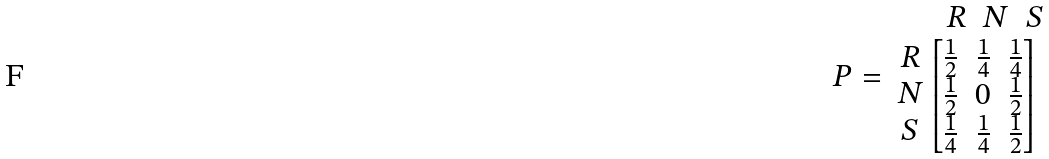<formula> <loc_0><loc_0><loc_500><loc_500>P = \begin{array} { r } \begin{matrix} R & N & S \end{matrix} \\ \begin{matrix} R \\ N \\ S \end{matrix} \begin{bmatrix} \frac { 1 } { 2 } & \frac { 1 } { 4 } & \frac { 1 } { 4 } \\ \frac { 1 } { 2 } & 0 & \frac { 1 } { 2 } \\ \frac { 1 } { 4 } & \frac { 1 } { 4 } & \frac { 1 } { 2 } \\ \end{bmatrix} \ \end{array}</formula> 